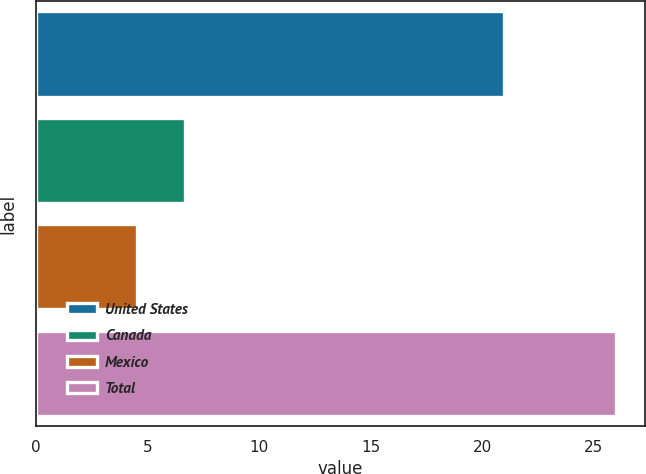<chart> <loc_0><loc_0><loc_500><loc_500><bar_chart><fcel>United States<fcel>Canada<fcel>Mexico<fcel>Total<nl><fcel>21<fcel>6.67<fcel>4.52<fcel>26<nl></chart> 